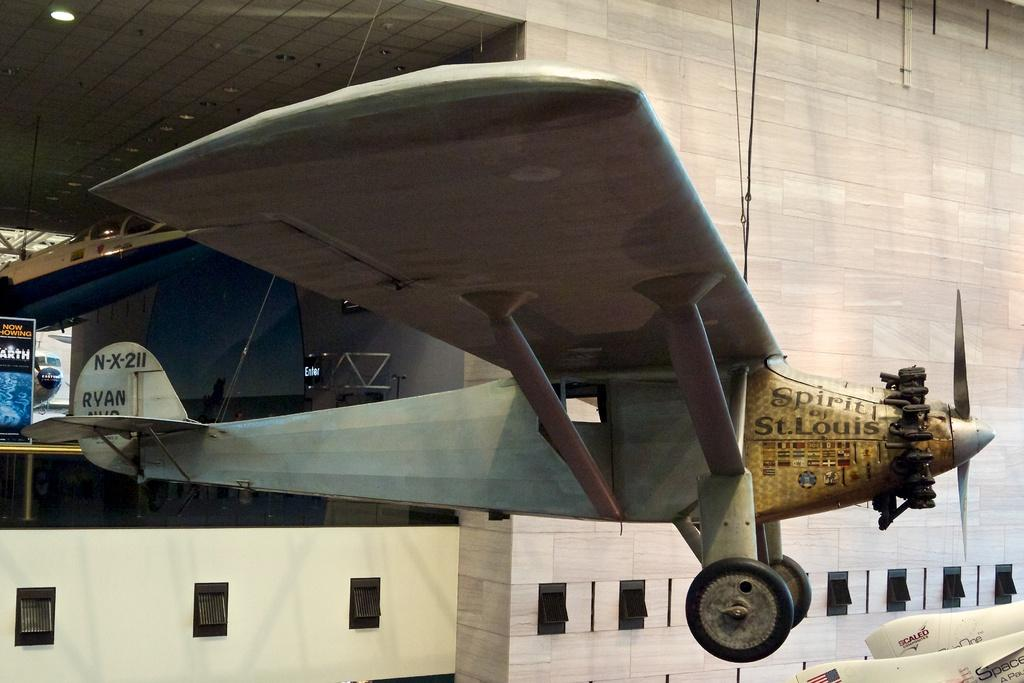<image>
Share a concise interpretation of the image provided. a jet with the words 'spirit of st. louis' on the front of it 